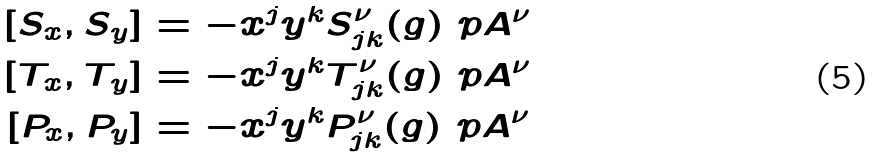Convert formula to latex. <formula><loc_0><loc_0><loc_500><loc_500>[ S _ { x } , S _ { y } ] & = - x ^ { j } y ^ { k } S ^ { \nu } _ { j k } ( g ) \ p { A ^ { \nu } } \\ [ T _ { x } , T _ { y } ] & = - x ^ { j } y ^ { k } T ^ { \nu } _ { j k } ( g ) \ p { A ^ { \nu } } \\ [ P _ { x } , P _ { y } ] & = - x ^ { j } y ^ { k } P ^ { \nu } _ { j k } ( g ) \ p { A ^ { \nu } }</formula> 